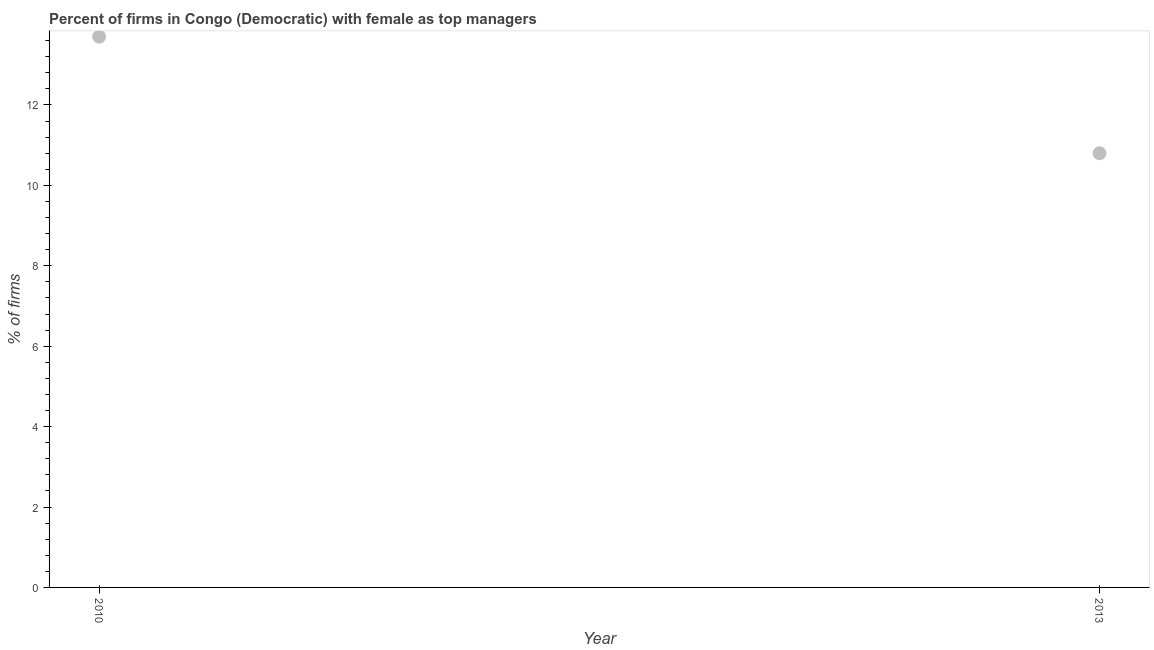Across all years, what is the maximum percentage of firms with female as top manager?
Offer a terse response. 13.7. Across all years, what is the minimum percentage of firms with female as top manager?
Make the answer very short. 10.8. What is the sum of the percentage of firms with female as top manager?
Your response must be concise. 24.5. What is the difference between the percentage of firms with female as top manager in 2010 and 2013?
Ensure brevity in your answer.  2.9. What is the average percentage of firms with female as top manager per year?
Provide a succinct answer. 12.25. What is the median percentage of firms with female as top manager?
Offer a very short reply. 12.25. What is the ratio of the percentage of firms with female as top manager in 2010 to that in 2013?
Make the answer very short. 1.27. Is the percentage of firms with female as top manager in 2010 less than that in 2013?
Your answer should be very brief. No. In how many years, is the percentage of firms with female as top manager greater than the average percentage of firms with female as top manager taken over all years?
Give a very brief answer. 1. Does the percentage of firms with female as top manager monotonically increase over the years?
Provide a succinct answer. No. How many dotlines are there?
Your answer should be very brief. 1. What is the difference between two consecutive major ticks on the Y-axis?
Offer a terse response. 2. Does the graph contain any zero values?
Keep it short and to the point. No. Does the graph contain grids?
Keep it short and to the point. No. What is the title of the graph?
Offer a terse response. Percent of firms in Congo (Democratic) with female as top managers. What is the label or title of the X-axis?
Provide a short and direct response. Year. What is the label or title of the Y-axis?
Offer a terse response. % of firms. What is the % of firms in 2010?
Make the answer very short. 13.7. What is the difference between the % of firms in 2010 and 2013?
Offer a terse response. 2.9. What is the ratio of the % of firms in 2010 to that in 2013?
Ensure brevity in your answer.  1.27. 